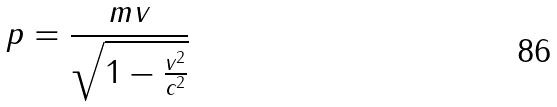<formula> <loc_0><loc_0><loc_500><loc_500>p = \frac { m v } { \sqrt { 1 - \frac { v ^ { 2 } } { c ^ { 2 } } } }</formula> 